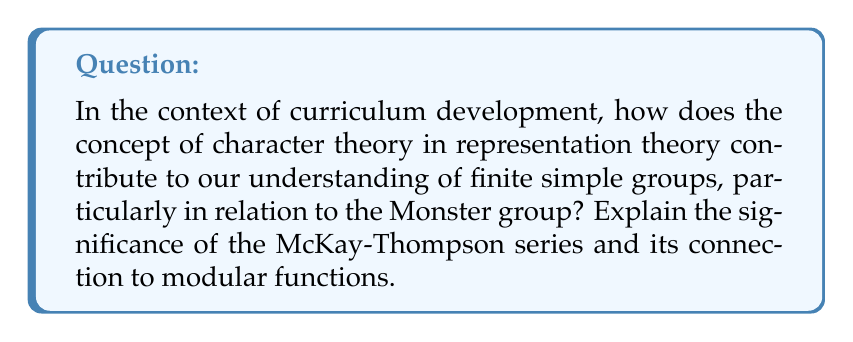Can you answer this question? To answer this question, let's break it down into steps:

1. Character Theory in Representation Theory:
   Character theory is a fundamental tool in representation theory. For a finite group $G$, a character $\chi$ is a function that assigns to each element $g \in G$ the trace of its representation matrix:

   $$\chi(g) = \text{Tr}(\rho(g))$$

   where $\rho$ is a representation of $G$.

2. Connection to Finite Simple Groups:
   Character theory plays a crucial role in the classification of finite simple groups. It provides a way to study the structure of groups through their representations.

3. The Monster Group:
   The Monster group, denoted by $\mathbb{M}$, is the largest sporadic simple group. It has approximately $8.08 \times 10^{53}$ elements.

4. McKay-Thompson Series:
   For each element $g$ of the Monster group, we can define a McKay-Thompson series:

   $$T_g(q) = \sum_{n=-1}^{\infty} \text{Tr}(g|V_n)q^n$$

   where $V_n$ are the graded components of a special infinite-dimensional representation of the Monster group called the Moonshine module.

5. Connection to Modular Functions:
   Remarkably, each McKay-Thompson series $T_g(q)$ is a hauptmodul for a genus zero subgroup of $SL_2(\mathbb{R})$. This means it's a modular function that generates the function field of a certain Riemann surface.

6. Monstrous Moonshine:
   This unexpected connection between the Monster group and modular functions is known as Monstrous Moonshine. It links two seemingly unrelated areas of mathematics: group theory and complex analysis.

7. Curriculum Implications:
   Understanding this connection showcases the interdisciplinary nature of advanced mathematics. It demonstrates how abstract algebra (group theory) connects with complex analysis and even touches on aspects of theoretical physics (through string theory).

This deep connection illustrates the unity of mathematics and can inspire curriculum development that emphasizes the interconnectedness of different mathematical disciplines.
Answer: McKay-Thompson series connect the Monster group's character theory to modular functions, revealing deep mathematical relationships. 